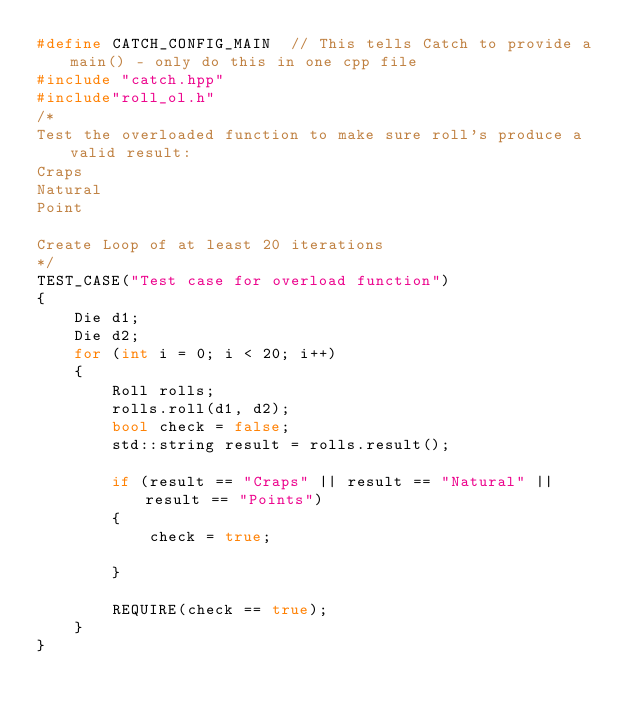<code> <loc_0><loc_0><loc_500><loc_500><_C++_>#define CATCH_CONFIG_MAIN  // This tells Catch to provide a main() - only do this in one cpp file
#include "catch.hpp"
#include"roll_ol.h"
/*
Test the overloaded function to make sure roll's produce a valid result:
Craps
Natural
Point

Create Loop of at least 20 iterations
*/
TEST_CASE("Test case for overload function")
{
	Die d1;
	Die d2;
	for (int i = 0; i < 20; i++)
	{
		Roll rolls;
		rolls.roll(d1, d2);
		bool check = false;
		std::string result = rolls.result();

		if (result == "Craps" || result == "Natural" || result == "Points")
		{
			check = true;

		}

		REQUIRE(check == true);
	}
}</code> 